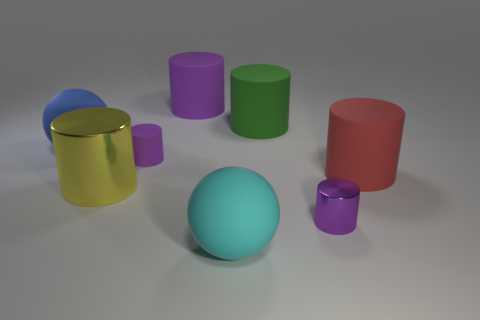Can you describe the colors and materials of the objects present? Certainly! There are seven cylindrical objects and one spherical object. Starting with the cylinders, we have two with a metallic sheen, one in gold and one in blue; two with a matte finish, in colors green and red; and three smaller ones, with glossy finishes in colors purple, lime green, and pink. The spherical object has a matte cyan color. 